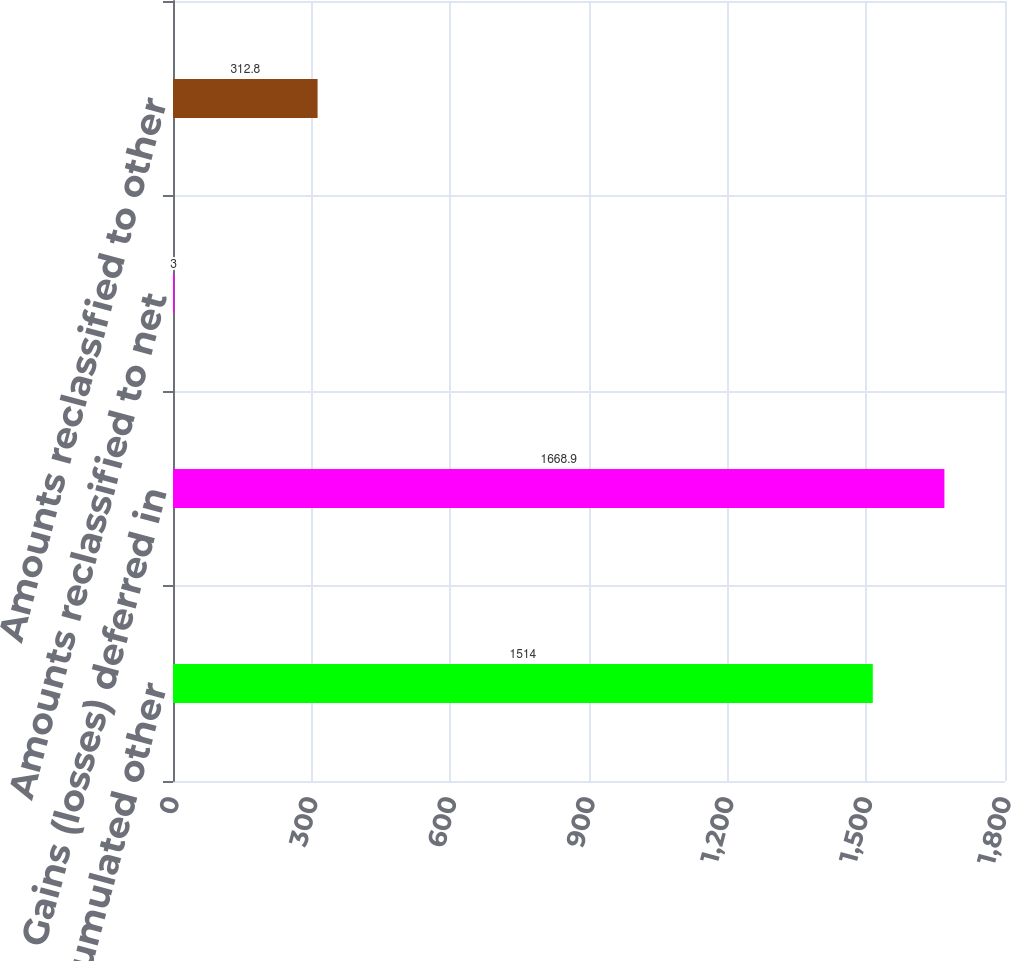<chart> <loc_0><loc_0><loc_500><loc_500><bar_chart><fcel>Accumulated other<fcel>Gains (losses) deferred in<fcel>Amounts reclassified to net<fcel>Amounts reclassified to other<nl><fcel>1514<fcel>1668.9<fcel>3<fcel>312.8<nl></chart> 